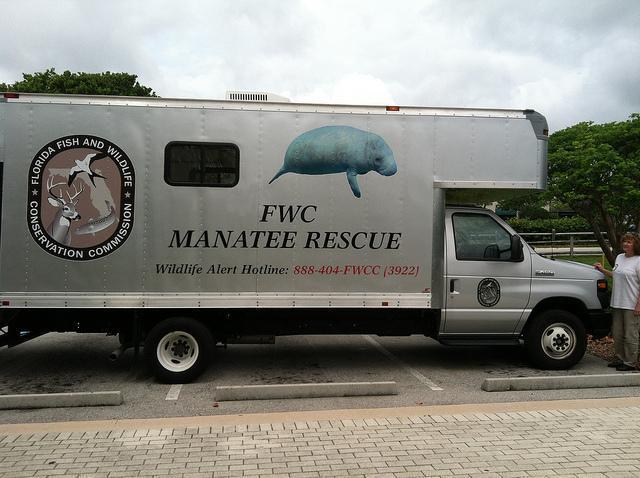How many people are there?
Give a very brief answer. 1. 